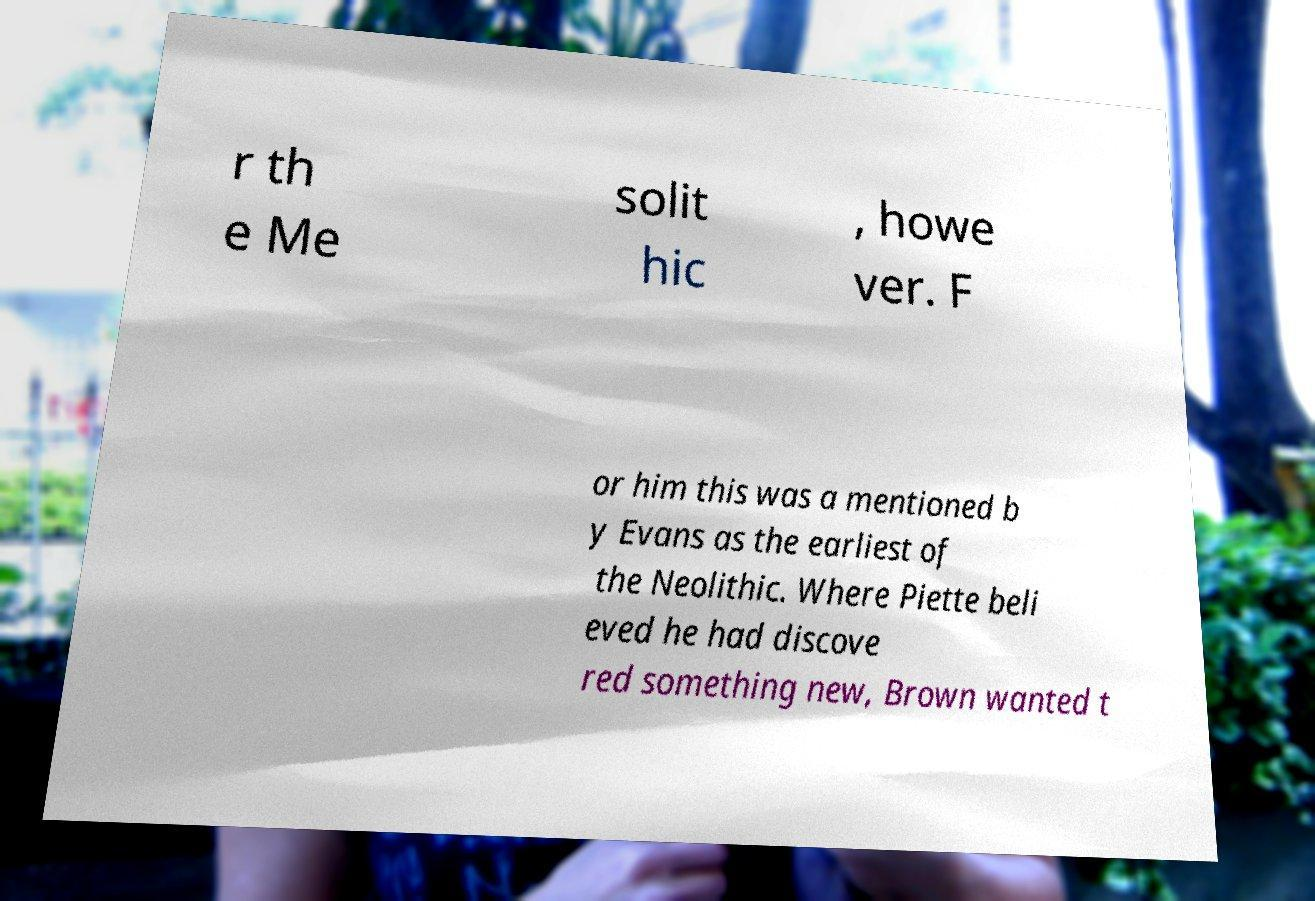I need the written content from this picture converted into text. Can you do that? r th e Me solit hic , howe ver. F or him this was a mentioned b y Evans as the earliest of the Neolithic. Where Piette beli eved he had discove red something new, Brown wanted t 